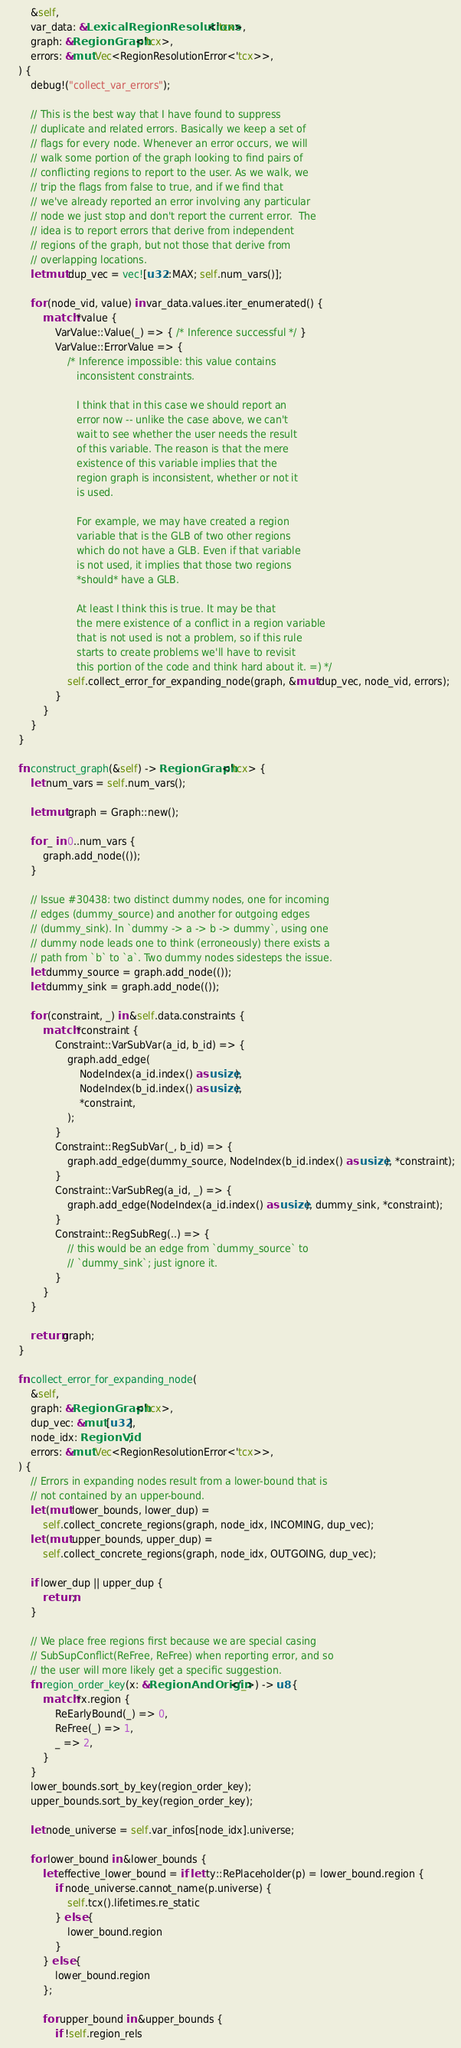<code> <loc_0><loc_0><loc_500><loc_500><_Rust_>        &self,
        var_data: &LexicalRegionResolutions<'tcx>,
        graph: &RegionGraph<'tcx>,
        errors: &mut Vec<RegionResolutionError<'tcx>>,
    ) {
        debug!("collect_var_errors");

        // This is the best way that I have found to suppress
        // duplicate and related errors. Basically we keep a set of
        // flags for every node. Whenever an error occurs, we will
        // walk some portion of the graph looking to find pairs of
        // conflicting regions to report to the user. As we walk, we
        // trip the flags from false to true, and if we find that
        // we've already reported an error involving any particular
        // node we just stop and don't report the current error.  The
        // idea is to report errors that derive from independent
        // regions of the graph, but not those that derive from
        // overlapping locations.
        let mut dup_vec = vec![u32::MAX; self.num_vars()];

        for (node_vid, value) in var_data.values.iter_enumerated() {
            match *value {
                VarValue::Value(_) => { /* Inference successful */ }
                VarValue::ErrorValue => {
                    /* Inference impossible: this value contains
                       inconsistent constraints.

                       I think that in this case we should report an
                       error now -- unlike the case above, we can't
                       wait to see whether the user needs the result
                       of this variable. The reason is that the mere
                       existence of this variable implies that the
                       region graph is inconsistent, whether or not it
                       is used.

                       For example, we may have created a region
                       variable that is the GLB of two other regions
                       which do not have a GLB. Even if that variable
                       is not used, it implies that those two regions
                       *should* have a GLB.

                       At least I think this is true. It may be that
                       the mere existence of a conflict in a region variable
                       that is not used is not a problem, so if this rule
                       starts to create problems we'll have to revisit
                       this portion of the code and think hard about it. =) */
                    self.collect_error_for_expanding_node(graph, &mut dup_vec, node_vid, errors);
                }
            }
        }
    }

    fn construct_graph(&self) -> RegionGraph<'tcx> {
        let num_vars = self.num_vars();

        let mut graph = Graph::new();

        for _ in 0..num_vars {
            graph.add_node(());
        }

        // Issue #30438: two distinct dummy nodes, one for incoming
        // edges (dummy_source) and another for outgoing edges
        // (dummy_sink). In `dummy -> a -> b -> dummy`, using one
        // dummy node leads one to think (erroneously) there exists a
        // path from `b` to `a`. Two dummy nodes sidesteps the issue.
        let dummy_source = graph.add_node(());
        let dummy_sink = graph.add_node(());

        for (constraint, _) in &self.data.constraints {
            match *constraint {
                Constraint::VarSubVar(a_id, b_id) => {
                    graph.add_edge(
                        NodeIndex(a_id.index() as usize),
                        NodeIndex(b_id.index() as usize),
                        *constraint,
                    );
                }
                Constraint::RegSubVar(_, b_id) => {
                    graph.add_edge(dummy_source, NodeIndex(b_id.index() as usize), *constraint);
                }
                Constraint::VarSubReg(a_id, _) => {
                    graph.add_edge(NodeIndex(a_id.index() as usize), dummy_sink, *constraint);
                }
                Constraint::RegSubReg(..) => {
                    // this would be an edge from `dummy_source` to
                    // `dummy_sink`; just ignore it.
                }
            }
        }

        return graph;
    }

    fn collect_error_for_expanding_node(
        &self,
        graph: &RegionGraph<'tcx>,
        dup_vec: &mut [u32],
        node_idx: RegionVid,
        errors: &mut Vec<RegionResolutionError<'tcx>>,
    ) {
        // Errors in expanding nodes result from a lower-bound that is
        // not contained by an upper-bound.
        let (mut lower_bounds, lower_dup) =
            self.collect_concrete_regions(graph, node_idx, INCOMING, dup_vec);
        let (mut upper_bounds, upper_dup) =
            self.collect_concrete_regions(graph, node_idx, OUTGOING, dup_vec);

        if lower_dup || upper_dup {
            return;
        }

        // We place free regions first because we are special casing
        // SubSupConflict(ReFree, ReFree) when reporting error, and so
        // the user will more likely get a specific suggestion.
        fn region_order_key(x: &RegionAndOrigin<'_>) -> u8 {
            match *x.region {
                ReEarlyBound(_) => 0,
                ReFree(_) => 1,
                _ => 2,
            }
        }
        lower_bounds.sort_by_key(region_order_key);
        upper_bounds.sort_by_key(region_order_key);

        let node_universe = self.var_infos[node_idx].universe;

        for lower_bound in &lower_bounds {
            let effective_lower_bound = if let ty::RePlaceholder(p) = lower_bound.region {
                if node_universe.cannot_name(p.universe) {
                    self.tcx().lifetimes.re_static
                } else {
                    lower_bound.region
                }
            } else {
                lower_bound.region
            };

            for upper_bound in &upper_bounds {
                if !self.region_rels</code> 